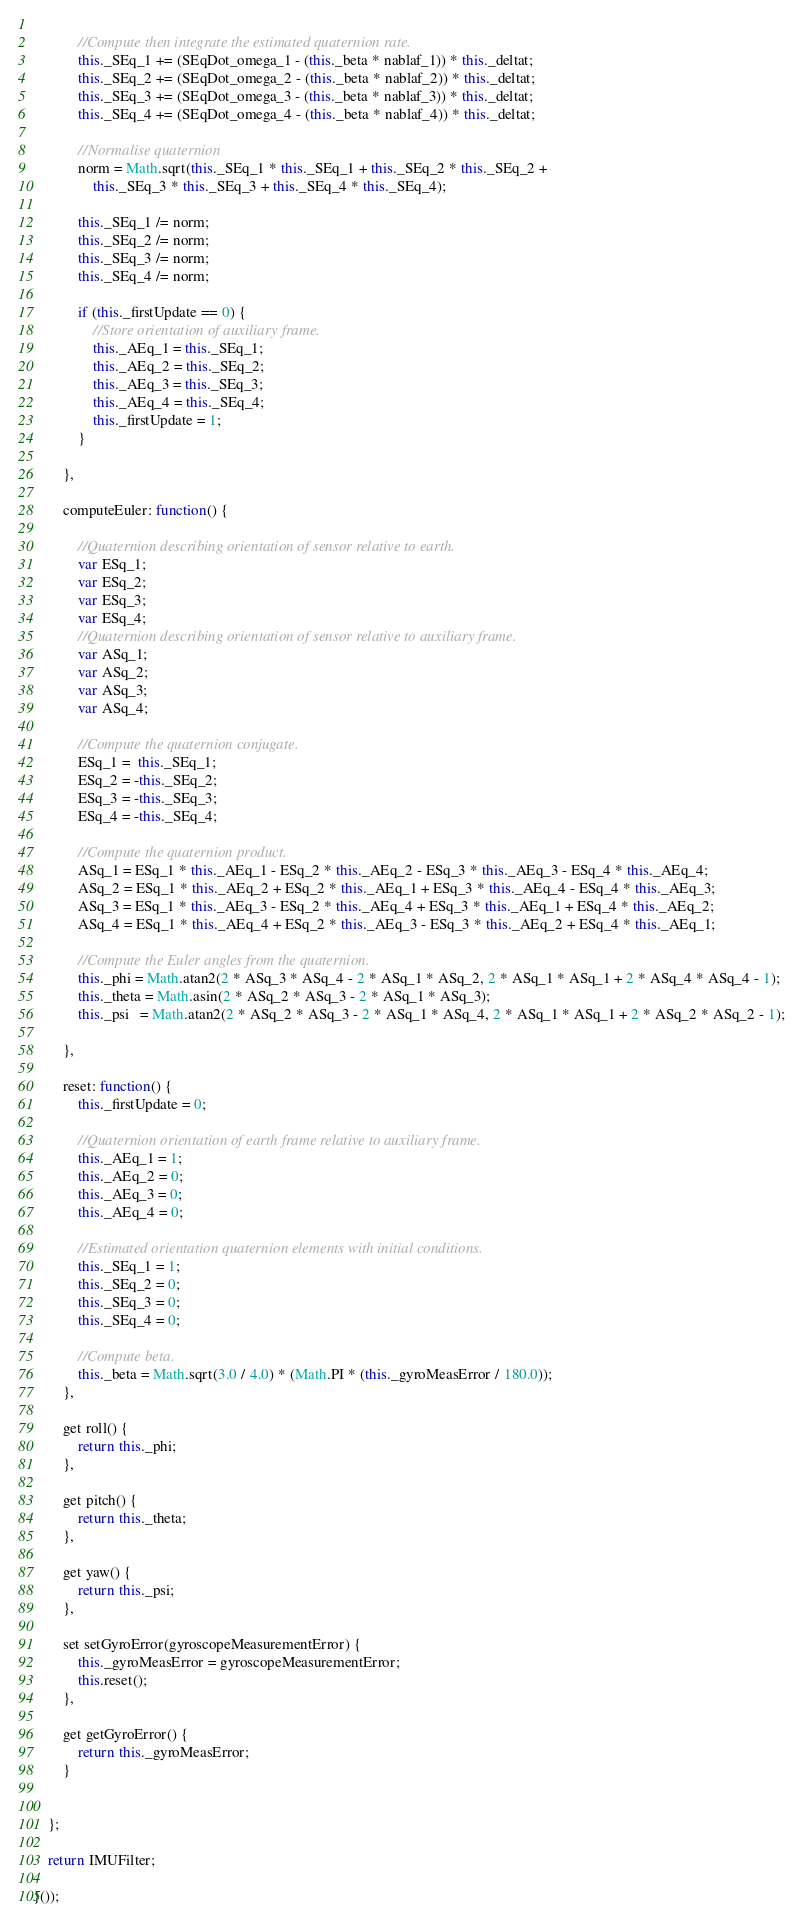<code> <loc_0><loc_0><loc_500><loc_500><_JavaScript_>			
			//Compute then integrate the estimated quaternion rate.
			this._SEq_1 += (SEqDot_omega_1 - (this._beta * nablaf_1)) * this._deltat;
			this._SEq_2 += (SEqDot_omega_2 - (this._beta * nablaf_2)) * this._deltat;
			this._SEq_3 += (SEqDot_omega_3 - (this._beta * nablaf_3)) * this._deltat;
			this._SEq_4 += (SEqDot_omega_4 - (this._beta * nablaf_4)) * this._deltat;
			
			//Normalise quaternion
			norm = Math.sqrt(this._SEq_1 * this._SEq_1 + this._SEq_2 * this._SEq_2 + 
				this._SEq_3 * this._SEq_3 + this._SEq_4 * this._SEq_4);			

			this._SEq_1 /= norm;
			this._SEq_2 /= norm;
			this._SEq_3 /= norm;
			this._SEq_4 /= norm;
			
			if (this._firstUpdate == 0) {
				//Store orientation of auxiliary frame.
				this._AEq_1 = this._SEq_1;
				this._AEq_2 = this._SEq_2;
				this._AEq_3 = this._SEq_3;
				this._AEq_4 = this._SEq_4;
				this._firstUpdate = 1;
			}
			
		},

		computeEuler: function() {
			
			//Quaternion describing orientation of sensor relative to earth.
			var ESq_1;
			var ESq_2;
			var ESq_3;
			var ESq_4;
			//Quaternion describing orientation of sensor relative to auxiliary frame.
			var ASq_1;
			var ASq_2;
			var ASq_3;
			var ASq_4;    
			
			//Compute the quaternion conjugate.
			ESq_1 =  this._SEq_1;
			ESq_2 = -this._SEq_2;
			ESq_3 = -this._SEq_3;
			ESq_4 = -this._SEq_4;
			
			//Compute the quaternion product.
			ASq_1 = ESq_1 * this._AEq_1 - ESq_2 * this._AEq_2 - ESq_3 * this._AEq_3 - ESq_4 * this._AEq_4;
			ASq_2 = ESq_1 * this._AEq_2 + ESq_2 * this._AEq_1 + ESq_3 * this._AEq_4 - ESq_4 * this._AEq_3;
			ASq_3 = ESq_1 * this._AEq_3 - ESq_2 * this._AEq_4 + ESq_3 * this._AEq_1 + ESq_4 * this._AEq_2;
			ASq_4 = ESq_1 * this._AEq_4 + ESq_2 * this._AEq_3 - ESq_3 * this._AEq_2 + ESq_4 * this._AEq_1;
			
			//Compute the Euler angles from the quaternion.
			this._phi = Math.atan2(2 * ASq_3 * ASq_4 - 2 * ASq_1 * ASq_2, 2 * ASq_1 * ASq_1 + 2 * ASq_4 * ASq_4 - 1);
			this._theta = Math.asin(2 * ASq_2 * ASq_3 - 2 * ASq_1 * ASq_3);
			this._psi   = Math.atan2(2 * ASq_2 * ASq_3 - 2 * ASq_1 * ASq_4, 2 * ASq_1 * ASq_1 + 2 * ASq_2 * ASq_2 - 1);
			
		},

		reset: function() {
			this._firstUpdate = 0;
			
			//Quaternion orientation of earth frame relative to auxiliary frame.
			this._AEq_1 = 1;
			this._AEq_2 = 0;
			this._AEq_3 = 0;
			this._AEq_4 = 0;
			
			//Estimated orientation quaternion elements with initial conditions.
			this._SEq_1 = 1;
			this._SEq_2 = 0;
			this._SEq_3 = 0;
			this._SEq_4 = 0;
			
			//Compute beta.
			this._beta = Math.sqrt(3.0 / 4.0) * (Math.PI * (this._gyroMeasError / 180.0));
		},

		get roll() {
			return this._phi;
		},

		get pitch() {
			return this._theta;
		},

		get yaw() {
			return this._psi;
		},

		set setGyroError(gyroscopeMeasurementError) {
			this._gyroMeasError = gyroscopeMeasurementError;
			this.reset();
		},
		
		get getGyroError() {
			return this._gyroMeasError;
		}		
		

	};

	return IMUFilter;

}());</code> 